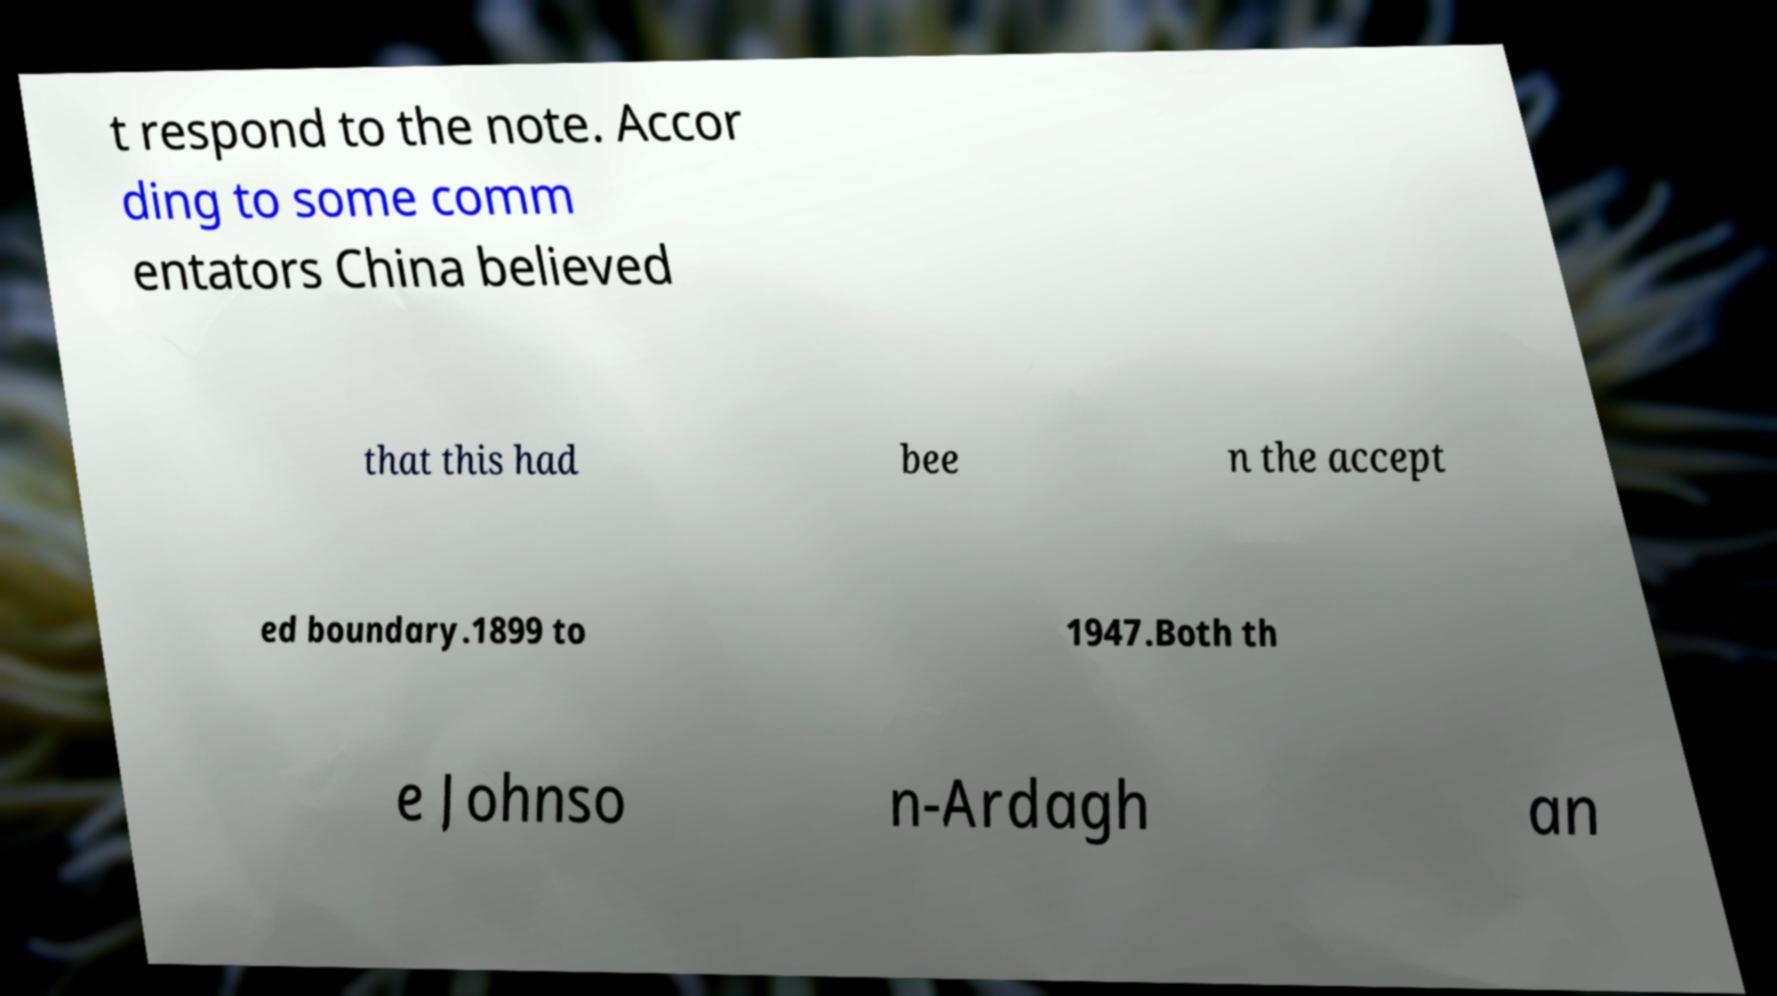I need the written content from this picture converted into text. Can you do that? t respond to the note. Accor ding to some comm entators China believed that this had bee n the accept ed boundary.1899 to 1947.Both th e Johnso n-Ardagh an 